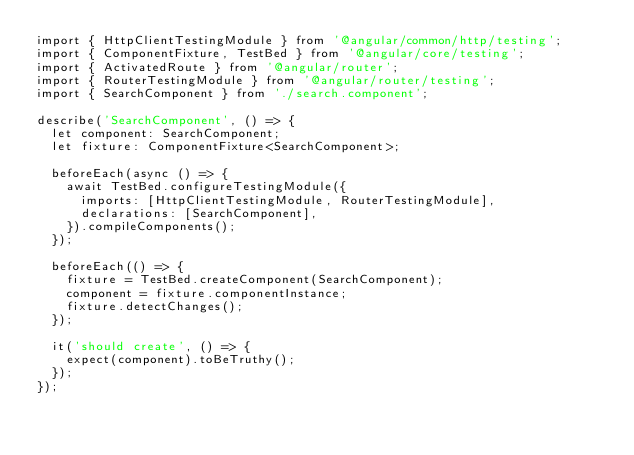<code> <loc_0><loc_0><loc_500><loc_500><_TypeScript_>import { HttpClientTestingModule } from '@angular/common/http/testing';
import { ComponentFixture, TestBed } from '@angular/core/testing';
import { ActivatedRoute } from '@angular/router';
import { RouterTestingModule } from '@angular/router/testing';
import { SearchComponent } from './search.component';

describe('SearchComponent', () => {
  let component: SearchComponent;
  let fixture: ComponentFixture<SearchComponent>;

  beforeEach(async () => {
    await TestBed.configureTestingModule({
      imports: [HttpClientTestingModule, RouterTestingModule],
      declarations: [SearchComponent],
    }).compileComponents();
  });

  beforeEach(() => {
    fixture = TestBed.createComponent(SearchComponent);
    component = fixture.componentInstance;
    fixture.detectChanges();
  });

  it('should create', () => {
    expect(component).toBeTruthy();
  });
});
</code> 